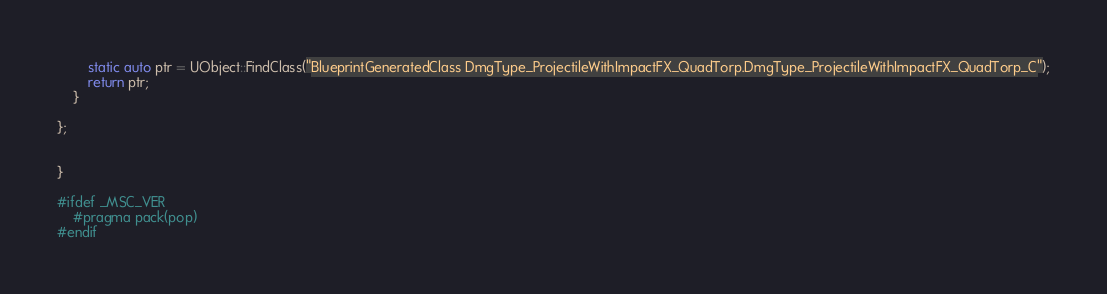<code> <loc_0><loc_0><loc_500><loc_500><_C++_>		static auto ptr = UObject::FindClass("BlueprintGeneratedClass DmgType_ProjectileWithImpactFX_QuadTorp.DmgType_ProjectileWithImpactFX_QuadTorp_C");
		return ptr;
	}

};


}

#ifdef _MSC_VER
	#pragma pack(pop)
#endif
</code> 